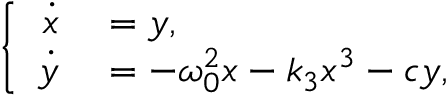<formula> <loc_0><loc_0><loc_500><loc_500>\left \{ \begin{array} { r l } { \dot { x } } & = y , } \\ { \dot { y } } & = - \omega _ { 0 } ^ { 2 } x - k _ { 3 } x ^ { 3 } - c y , } \end{array}</formula> 